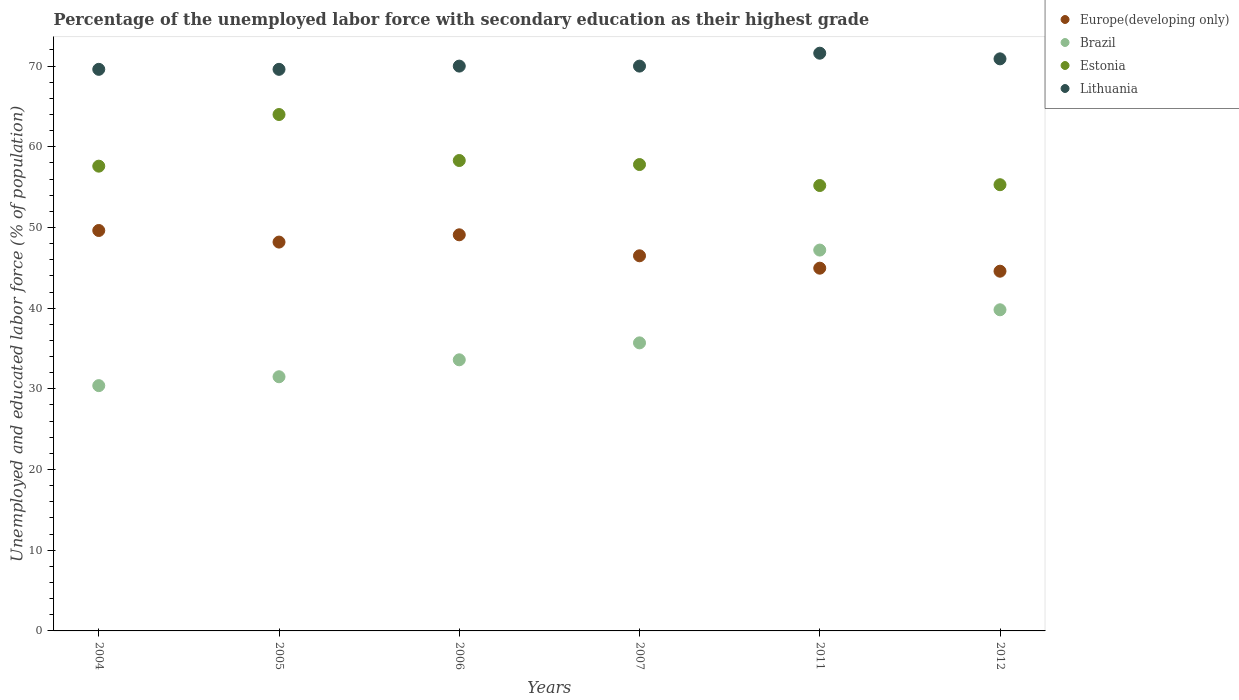Is the number of dotlines equal to the number of legend labels?
Give a very brief answer. Yes. What is the percentage of the unemployed labor force with secondary education in Lithuania in 2011?
Your answer should be compact. 71.6. Across all years, what is the maximum percentage of the unemployed labor force with secondary education in Lithuania?
Your answer should be very brief. 71.6. Across all years, what is the minimum percentage of the unemployed labor force with secondary education in Brazil?
Offer a very short reply. 30.4. In which year was the percentage of the unemployed labor force with secondary education in Europe(developing only) maximum?
Give a very brief answer. 2004. In which year was the percentage of the unemployed labor force with secondary education in Europe(developing only) minimum?
Your answer should be compact. 2012. What is the total percentage of the unemployed labor force with secondary education in Brazil in the graph?
Your response must be concise. 218.2. What is the difference between the percentage of the unemployed labor force with secondary education in Lithuania in 2004 and the percentage of the unemployed labor force with secondary education in Europe(developing only) in 2012?
Provide a short and direct response. 25.02. What is the average percentage of the unemployed labor force with secondary education in Estonia per year?
Keep it short and to the point. 58.03. In the year 2012, what is the difference between the percentage of the unemployed labor force with secondary education in Estonia and percentage of the unemployed labor force with secondary education in Brazil?
Your answer should be compact. 15.5. In how many years, is the percentage of the unemployed labor force with secondary education in Estonia greater than 38 %?
Provide a short and direct response. 6. What is the ratio of the percentage of the unemployed labor force with secondary education in Brazil in 2005 to that in 2011?
Your response must be concise. 0.67. Is the percentage of the unemployed labor force with secondary education in Lithuania in 2007 less than that in 2011?
Provide a short and direct response. Yes. Is the difference between the percentage of the unemployed labor force with secondary education in Estonia in 2005 and 2012 greater than the difference between the percentage of the unemployed labor force with secondary education in Brazil in 2005 and 2012?
Offer a terse response. Yes. What is the difference between the highest and the second highest percentage of the unemployed labor force with secondary education in Estonia?
Give a very brief answer. 5.7. What is the difference between the highest and the lowest percentage of the unemployed labor force with secondary education in Europe(developing only)?
Ensure brevity in your answer.  5.04. In how many years, is the percentage of the unemployed labor force with secondary education in Lithuania greater than the average percentage of the unemployed labor force with secondary education in Lithuania taken over all years?
Provide a short and direct response. 2. Is the sum of the percentage of the unemployed labor force with secondary education in Europe(developing only) in 2005 and 2006 greater than the maximum percentage of the unemployed labor force with secondary education in Estonia across all years?
Keep it short and to the point. Yes. Is the percentage of the unemployed labor force with secondary education in Brazil strictly greater than the percentage of the unemployed labor force with secondary education in Lithuania over the years?
Keep it short and to the point. No. Is the percentage of the unemployed labor force with secondary education in Estonia strictly less than the percentage of the unemployed labor force with secondary education in Lithuania over the years?
Your response must be concise. Yes. How many dotlines are there?
Your answer should be very brief. 4. How many years are there in the graph?
Your answer should be compact. 6. What is the difference between two consecutive major ticks on the Y-axis?
Give a very brief answer. 10. Does the graph contain grids?
Your response must be concise. No. Where does the legend appear in the graph?
Offer a very short reply. Top right. How many legend labels are there?
Offer a very short reply. 4. What is the title of the graph?
Your answer should be compact. Percentage of the unemployed labor force with secondary education as their highest grade. Does "European Union" appear as one of the legend labels in the graph?
Make the answer very short. No. What is the label or title of the X-axis?
Your response must be concise. Years. What is the label or title of the Y-axis?
Your answer should be compact. Unemployed and educated labor force (% of population). What is the Unemployed and educated labor force (% of population) in Europe(developing only) in 2004?
Provide a succinct answer. 49.63. What is the Unemployed and educated labor force (% of population) of Brazil in 2004?
Provide a short and direct response. 30.4. What is the Unemployed and educated labor force (% of population) of Estonia in 2004?
Your answer should be very brief. 57.6. What is the Unemployed and educated labor force (% of population) of Lithuania in 2004?
Your answer should be compact. 69.6. What is the Unemployed and educated labor force (% of population) of Europe(developing only) in 2005?
Your response must be concise. 48.19. What is the Unemployed and educated labor force (% of population) in Brazil in 2005?
Make the answer very short. 31.5. What is the Unemployed and educated labor force (% of population) of Estonia in 2005?
Offer a terse response. 64. What is the Unemployed and educated labor force (% of population) of Lithuania in 2005?
Make the answer very short. 69.6. What is the Unemployed and educated labor force (% of population) of Europe(developing only) in 2006?
Offer a terse response. 49.09. What is the Unemployed and educated labor force (% of population) of Brazil in 2006?
Make the answer very short. 33.6. What is the Unemployed and educated labor force (% of population) of Estonia in 2006?
Your answer should be very brief. 58.3. What is the Unemployed and educated labor force (% of population) of Lithuania in 2006?
Offer a terse response. 70. What is the Unemployed and educated labor force (% of population) of Europe(developing only) in 2007?
Give a very brief answer. 46.49. What is the Unemployed and educated labor force (% of population) of Brazil in 2007?
Your answer should be compact. 35.7. What is the Unemployed and educated labor force (% of population) of Estonia in 2007?
Make the answer very short. 57.8. What is the Unemployed and educated labor force (% of population) in Europe(developing only) in 2011?
Keep it short and to the point. 44.96. What is the Unemployed and educated labor force (% of population) of Brazil in 2011?
Offer a terse response. 47.2. What is the Unemployed and educated labor force (% of population) in Estonia in 2011?
Make the answer very short. 55.2. What is the Unemployed and educated labor force (% of population) in Lithuania in 2011?
Give a very brief answer. 71.6. What is the Unemployed and educated labor force (% of population) of Europe(developing only) in 2012?
Offer a very short reply. 44.58. What is the Unemployed and educated labor force (% of population) of Brazil in 2012?
Provide a short and direct response. 39.8. What is the Unemployed and educated labor force (% of population) of Estonia in 2012?
Keep it short and to the point. 55.3. What is the Unemployed and educated labor force (% of population) of Lithuania in 2012?
Provide a short and direct response. 70.9. Across all years, what is the maximum Unemployed and educated labor force (% of population) of Europe(developing only)?
Your answer should be very brief. 49.63. Across all years, what is the maximum Unemployed and educated labor force (% of population) in Brazil?
Make the answer very short. 47.2. Across all years, what is the maximum Unemployed and educated labor force (% of population) of Lithuania?
Your response must be concise. 71.6. Across all years, what is the minimum Unemployed and educated labor force (% of population) in Europe(developing only)?
Offer a very short reply. 44.58. Across all years, what is the minimum Unemployed and educated labor force (% of population) in Brazil?
Provide a succinct answer. 30.4. Across all years, what is the minimum Unemployed and educated labor force (% of population) of Estonia?
Keep it short and to the point. 55.2. Across all years, what is the minimum Unemployed and educated labor force (% of population) in Lithuania?
Your answer should be very brief. 69.6. What is the total Unemployed and educated labor force (% of population) of Europe(developing only) in the graph?
Your answer should be very brief. 282.94. What is the total Unemployed and educated labor force (% of population) of Brazil in the graph?
Offer a very short reply. 218.2. What is the total Unemployed and educated labor force (% of population) in Estonia in the graph?
Provide a short and direct response. 348.2. What is the total Unemployed and educated labor force (% of population) of Lithuania in the graph?
Provide a succinct answer. 421.7. What is the difference between the Unemployed and educated labor force (% of population) of Europe(developing only) in 2004 and that in 2005?
Give a very brief answer. 1.44. What is the difference between the Unemployed and educated labor force (% of population) of Lithuania in 2004 and that in 2005?
Give a very brief answer. 0. What is the difference between the Unemployed and educated labor force (% of population) in Europe(developing only) in 2004 and that in 2006?
Your response must be concise. 0.53. What is the difference between the Unemployed and educated labor force (% of population) of Brazil in 2004 and that in 2006?
Your response must be concise. -3.2. What is the difference between the Unemployed and educated labor force (% of population) of Estonia in 2004 and that in 2006?
Your response must be concise. -0.7. What is the difference between the Unemployed and educated labor force (% of population) in Europe(developing only) in 2004 and that in 2007?
Keep it short and to the point. 3.14. What is the difference between the Unemployed and educated labor force (% of population) in Brazil in 2004 and that in 2007?
Provide a succinct answer. -5.3. What is the difference between the Unemployed and educated labor force (% of population) of Estonia in 2004 and that in 2007?
Your response must be concise. -0.2. What is the difference between the Unemployed and educated labor force (% of population) in Europe(developing only) in 2004 and that in 2011?
Offer a very short reply. 4.67. What is the difference between the Unemployed and educated labor force (% of population) in Brazil in 2004 and that in 2011?
Make the answer very short. -16.8. What is the difference between the Unemployed and educated labor force (% of population) of Estonia in 2004 and that in 2011?
Your response must be concise. 2.4. What is the difference between the Unemployed and educated labor force (% of population) of Lithuania in 2004 and that in 2011?
Ensure brevity in your answer.  -2. What is the difference between the Unemployed and educated labor force (% of population) of Europe(developing only) in 2004 and that in 2012?
Your response must be concise. 5.04. What is the difference between the Unemployed and educated labor force (% of population) in Brazil in 2004 and that in 2012?
Your answer should be compact. -9.4. What is the difference between the Unemployed and educated labor force (% of population) in Lithuania in 2004 and that in 2012?
Offer a terse response. -1.3. What is the difference between the Unemployed and educated labor force (% of population) in Europe(developing only) in 2005 and that in 2006?
Offer a terse response. -0.9. What is the difference between the Unemployed and educated labor force (% of population) in Estonia in 2005 and that in 2006?
Offer a very short reply. 5.7. What is the difference between the Unemployed and educated labor force (% of population) of Europe(developing only) in 2005 and that in 2007?
Offer a very short reply. 1.7. What is the difference between the Unemployed and educated labor force (% of population) in Brazil in 2005 and that in 2007?
Provide a succinct answer. -4.2. What is the difference between the Unemployed and educated labor force (% of population) of Estonia in 2005 and that in 2007?
Your answer should be very brief. 6.2. What is the difference between the Unemployed and educated labor force (% of population) of Lithuania in 2005 and that in 2007?
Make the answer very short. -0.4. What is the difference between the Unemployed and educated labor force (% of population) in Europe(developing only) in 2005 and that in 2011?
Provide a short and direct response. 3.23. What is the difference between the Unemployed and educated labor force (% of population) of Brazil in 2005 and that in 2011?
Give a very brief answer. -15.7. What is the difference between the Unemployed and educated labor force (% of population) in Estonia in 2005 and that in 2011?
Provide a short and direct response. 8.8. What is the difference between the Unemployed and educated labor force (% of population) in Europe(developing only) in 2005 and that in 2012?
Give a very brief answer. 3.61. What is the difference between the Unemployed and educated labor force (% of population) in Europe(developing only) in 2006 and that in 2007?
Provide a short and direct response. 2.6. What is the difference between the Unemployed and educated labor force (% of population) in Brazil in 2006 and that in 2007?
Make the answer very short. -2.1. What is the difference between the Unemployed and educated labor force (% of population) of Lithuania in 2006 and that in 2007?
Provide a short and direct response. 0. What is the difference between the Unemployed and educated labor force (% of population) in Europe(developing only) in 2006 and that in 2011?
Make the answer very short. 4.14. What is the difference between the Unemployed and educated labor force (% of population) in Brazil in 2006 and that in 2011?
Ensure brevity in your answer.  -13.6. What is the difference between the Unemployed and educated labor force (% of population) in Europe(developing only) in 2006 and that in 2012?
Give a very brief answer. 4.51. What is the difference between the Unemployed and educated labor force (% of population) in Brazil in 2006 and that in 2012?
Provide a succinct answer. -6.2. What is the difference between the Unemployed and educated labor force (% of population) in Europe(developing only) in 2007 and that in 2011?
Offer a terse response. 1.53. What is the difference between the Unemployed and educated labor force (% of population) in Brazil in 2007 and that in 2011?
Your answer should be very brief. -11.5. What is the difference between the Unemployed and educated labor force (% of population) in Lithuania in 2007 and that in 2011?
Ensure brevity in your answer.  -1.6. What is the difference between the Unemployed and educated labor force (% of population) in Europe(developing only) in 2007 and that in 2012?
Provide a short and direct response. 1.91. What is the difference between the Unemployed and educated labor force (% of population) in Lithuania in 2007 and that in 2012?
Your answer should be very brief. -0.9. What is the difference between the Unemployed and educated labor force (% of population) of Europe(developing only) in 2011 and that in 2012?
Provide a succinct answer. 0.37. What is the difference between the Unemployed and educated labor force (% of population) in Brazil in 2011 and that in 2012?
Ensure brevity in your answer.  7.4. What is the difference between the Unemployed and educated labor force (% of population) of Europe(developing only) in 2004 and the Unemployed and educated labor force (% of population) of Brazil in 2005?
Provide a short and direct response. 18.13. What is the difference between the Unemployed and educated labor force (% of population) in Europe(developing only) in 2004 and the Unemployed and educated labor force (% of population) in Estonia in 2005?
Ensure brevity in your answer.  -14.37. What is the difference between the Unemployed and educated labor force (% of population) in Europe(developing only) in 2004 and the Unemployed and educated labor force (% of population) in Lithuania in 2005?
Provide a short and direct response. -19.97. What is the difference between the Unemployed and educated labor force (% of population) of Brazil in 2004 and the Unemployed and educated labor force (% of population) of Estonia in 2005?
Keep it short and to the point. -33.6. What is the difference between the Unemployed and educated labor force (% of population) in Brazil in 2004 and the Unemployed and educated labor force (% of population) in Lithuania in 2005?
Offer a terse response. -39.2. What is the difference between the Unemployed and educated labor force (% of population) of Estonia in 2004 and the Unemployed and educated labor force (% of population) of Lithuania in 2005?
Provide a short and direct response. -12. What is the difference between the Unemployed and educated labor force (% of population) in Europe(developing only) in 2004 and the Unemployed and educated labor force (% of population) in Brazil in 2006?
Make the answer very short. 16.03. What is the difference between the Unemployed and educated labor force (% of population) of Europe(developing only) in 2004 and the Unemployed and educated labor force (% of population) of Estonia in 2006?
Your response must be concise. -8.67. What is the difference between the Unemployed and educated labor force (% of population) in Europe(developing only) in 2004 and the Unemployed and educated labor force (% of population) in Lithuania in 2006?
Make the answer very short. -20.37. What is the difference between the Unemployed and educated labor force (% of population) in Brazil in 2004 and the Unemployed and educated labor force (% of population) in Estonia in 2006?
Offer a very short reply. -27.9. What is the difference between the Unemployed and educated labor force (% of population) of Brazil in 2004 and the Unemployed and educated labor force (% of population) of Lithuania in 2006?
Provide a short and direct response. -39.6. What is the difference between the Unemployed and educated labor force (% of population) in Estonia in 2004 and the Unemployed and educated labor force (% of population) in Lithuania in 2006?
Give a very brief answer. -12.4. What is the difference between the Unemployed and educated labor force (% of population) in Europe(developing only) in 2004 and the Unemployed and educated labor force (% of population) in Brazil in 2007?
Keep it short and to the point. 13.93. What is the difference between the Unemployed and educated labor force (% of population) in Europe(developing only) in 2004 and the Unemployed and educated labor force (% of population) in Estonia in 2007?
Provide a succinct answer. -8.17. What is the difference between the Unemployed and educated labor force (% of population) of Europe(developing only) in 2004 and the Unemployed and educated labor force (% of population) of Lithuania in 2007?
Offer a very short reply. -20.37. What is the difference between the Unemployed and educated labor force (% of population) of Brazil in 2004 and the Unemployed and educated labor force (% of population) of Estonia in 2007?
Give a very brief answer. -27.4. What is the difference between the Unemployed and educated labor force (% of population) of Brazil in 2004 and the Unemployed and educated labor force (% of population) of Lithuania in 2007?
Your response must be concise. -39.6. What is the difference between the Unemployed and educated labor force (% of population) of Europe(developing only) in 2004 and the Unemployed and educated labor force (% of population) of Brazil in 2011?
Keep it short and to the point. 2.43. What is the difference between the Unemployed and educated labor force (% of population) in Europe(developing only) in 2004 and the Unemployed and educated labor force (% of population) in Estonia in 2011?
Ensure brevity in your answer.  -5.57. What is the difference between the Unemployed and educated labor force (% of population) of Europe(developing only) in 2004 and the Unemployed and educated labor force (% of population) of Lithuania in 2011?
Offer a terse response. -21.97. What is the difference between the Unemployed and educated labor force (% of population) of Brazil in 2004 and the Unemployed and educated labor force (% of population) of Estonia in 2011?
Offer a very short reply. -24.8. What is the difference between the Unemployed and educated labor force (% of population) in Brazil in 2004 and the Unemployed and educated labor force (% of population) in Lithuania in 2011?
Make the answer very short. -41.2. What is the difference between the Unemployed and educated labor force (% of population) of Estonia in 2004 and the Unemployed and educated labor force (% of population) of Lithuania in 2011?
Provide a succinct answer. -14. What is the difference between the Unemployed and educated labor force (% of population) in Europe(developing only) in 2004 and the Unemployed and educated labor force (% of population) in Brazil in 2012?
Offer a very short reply. 9.83. What is the difference between the Unemployed and educated labor force (% of population) of Europe(developing only) in 2004 and the Unemployed and educated labor force (% of population) of Estonia in 2012?
Offer a terse response. -5.67. What is the difference between the Unemployed and educated labor force (% of population) in Europe(developing only) in 2004 and the Unemployed and educated labor force (% of population) in Lithuania in 2012?
Keep it short and to the point. -21.27. What is the difference between the Unemployed and educated labor force (% of population) in Brazil in 2004 and the Unemployed and educated labor force (% of population) in Estonia in 2012?
Provide a succinct answer. -24.9. What is the difference between the Unemployed and educated labor force (% of population) of Brazil in 2004 and the Unemployed and educated labor force (% of population) of Lithuania in 2012?
Your answer should be compact. -40.5. What is the difference between the Unemployed and educated labor force (% of population) in Europe(developing only) in 2005 and the Unemployed and educated labor force (% of population) in Brazil in 2006?
Provide a succinct answer. 14.59. What is the difference between the Unemployed and educated labor force (% of population) in Europe(developing only) in 2005 and the Unemployed and educated labor force (% of population) in Estonia in 2006?
Provide a succinct answer. -10.11. What is the difference between the Unemployed and educated labor force (% of population) in Europe(developing only) in 2005 and the Unemployed and educated labor force (% of population) in Lithuania in 2006?
Ensure brevity in your answer.  -21.81. What is the difference between the Unemployed and educated labor force (% of population) of Brazil in 2005 and the Unemployed and educated labor force (% of population) of Estonia in 2006?
Make the answer very short. -26.8. What is the difference between the Unemployed and educated labor force (% of population) in Brazil in 2005 and the Unemployed and educated labor force (% of population) in Lithuania in 2006?
Your answer should be very brief. -38.5. What is the difference between the Unemployed and educated labor force (% of population) of Europe(developing only) in 2005 and the Unemployed and educated labor force (% of population) of Brazil in 2007?
Ensure brevity in your answer.  12.49. What is the difference between the Unemployed and educated labor force (% of population) of Europe(developing only) in 2005 and the Unemployed and educated labor force (% of population) of Estonia in 2007?
Your answer should be compact. -9.61. What is the difference between the Unemployed and educated labor force (% of population) in Europe(developing only) in 2005 and the Unemployed and educated labor force (% of population) in Lithuania in 2007?
Ensure brevity in your answer.  -21.81. What is the difference between the Unemployed and educated labor force (% of population) in Brazil in 2005 and the Unemployed and educated labor force (% of population) in Estonia in 2007?
Provide a succinct answer. -26.3. What is the difference between the Unemployed and educated labor force (% of population) of Brazil in 2005 and the Unemployed and educated labor force (% of population) of Lithuania in 2007?
Your response must be concise. -38.5. What is the difference between the Unemployed and educated labor force (% of population) of Europe(developing only) in 2005 and the Unemployed and educated labor force (% of population) of Brazil in 2011?
Make the answer very short. 0.99. What is the difference between the Unemployed and educated labor force (% of population) in Europe(developing only) in 2005 and the Unemployed and educated labor force (% of population) in Estonia in 2011?
Your response must be concise. -7.01. What is the difference between the Unemployed and educated labor force (% of population) in Europe(developing only) in 2005 and the Unemployed and educated labor force (% of population) in Lithuania in 2011?
Keep it short and to the point. -23.41. What is the difference between the Unemployed and educated labor force (% of population) of Brazil in 2005 and the Unemployed and educated labor force (% of population) of Estonia in 2011?
Keep it short and to the point. -23.7. What is the difference between the Unemployed and educated labor force (% of population) of Brazil in 2005 and the Unemployed and educated labor force (% of population) of Lithuania in 2011?
Provide a short and direct response. -40.1. What is the difference between the Unemployed and educated labor force (% of population) in Estonia in 2005 and the Unemployed and educated labor force (% of population) in Lithuania in 2011?
Your response must be concise. -7.6. What is the difference between the Unemployed and educated labor force (% of population) in Europe(developing only) in 2005 and the Unemployed and educated labor force (% of population) in Brazil in 2012?
Make the answer very short. 8.39. What is the difference between the Unemployed and educated labor force (% of population) in Europe(developing only) in 2005 and the Unemployed and educated labor force (% of population) in Estonia in 2012?
Ensure brevity in your answer.  -7.11. What is the difference between the Unemployed and educated labor force (% of population) in Europe(developing only) in 2005 and the Unemployed and educated labor force (% of population) in Lithuania in 2012?
Provide a short and direct response. -22.71. What is the difference between the Unemployed and educated labor force (% of population) in Brazil in 2005 and the Unemployed and educated labor force (% of population) in Estonia in 2012?
Your answer should be compact. -23.8. What is the difference between the Unemployed and educated labor force (% of population) in Brazil in 2005 and the Unemployed and educated labor force (% of population) in Lithuania in 2012?
Your response must be concise. -39.4. What is the difference between the Unemployed and educated labor force (% of population) in Europe(developing only) in 2006 and the Unemployed and educated labor force (% of population) in Brazil in 2007?
Your answer should be very brief. 13.39. What is the difference between the Unemployed and educated labor force (% of population) in Europe(developing only) in 2006 and the Unemployed and educated labor force (% of population) in Estonia in 2007?
Your answer should be very brief. -8.71. What is the difference between the Unemployed and educated labor force (% of population) of Europe(developing only) in 2006 and the Unemployed and educated labor force (% of population) of Lithuania in 2007?
Give a very brief answer. -20.91. What is the difference between the Unemployed and educated labor force (% of population) in Brazil in 2006 and the Unemployed and educated labor force (% of population) in Estonia in 2007?
Keep it short and to the point. -24.2. What is the difference between the Unemployed and educated labor force (% of population) in Brazil in 2006 and the Unemployed and educated labor force (% of population) in Lithuania in 2007?
Give a very brief answer. -36.4. What is the difference between the Unemployed and educated labor force (% of population) in Europe(developing only) in 2006 and the Unemployed and educated labor force (% of population) in Brazil in 2011?
Provide a short and direct response. 1.89. What is the difference between the Unemployed and educated labor force (% of population) of Europe(developing only) in 2006 and the Unemployed and educated labor force (% of population) of Estonia in 2011?
Your answer should be very brief. -6.11. What is the difference between the Unemployed and educated labor force (% of population) in Europe(developing only) in 2006 and the Unemployed and educated labor force (% of population) in Lithuania in 2011?
Keep it short and to the point. -22.51. What is the difference between the Unemployed and educated labor force (% of population) of Brazil in 2006 and the Unemployed and educated labor force (% of population) of Estonia in 2011?
Offer a terse response. -21.6. What is the difference between the Unemployed and educated labor force (% of population) of Brazil in 2006 and the Unemployed and educated labor force (% of population) of Lithuania in 2011?
Keep it short and to the point. -38. What is the difference between the Unemployed and educated labor force (% of population) of Estonia in 2006 and the Unemployed and educated labor force (% of population) of Lithuania in 2011?
Make the answer very short. -13.3. What is the difference between the Unemployed and educated labor force (% of population) of Europe(developing only) in 2006 and the Unemployed and educated labor force (% of population) of Brazil in 2012?
Give a very brief answer. 9.29. What is the difference between the Unemployed and educated labor force (% of population) in Europe(developing only) in 2006 and the Unemployed and educated labor force (% of population) in Estonia in 2012?
Your answer should be very brief. -6.21. What is the difference between the Unemployed and educated labor force (% of population) of Europe(developing only) in 2006 and the Unemployed and educated labor force (% of population) of Lithuania in 2012?
Provide a short and direct response. -21.81. What is the difference between the Unemployed and educated labor force (% of population) in Brazil in 2006 and the Unemployed and educated labor force (% of population) in Estonia in 2012?
Your response must be concise. -21.7. What is the difference between the Unemployed and educated labor force (% of population) in Brazil in 2006 and the Unemployed and educated labor force (% of population) in Lithuania in 2012?
Your answer should be compact. -37.3. What is the difference between the Unemployed and educated labor force (% of population) in Europe(developing only) in 2007 and the Unemployed and educated labor force (% of population) in Brazil in 2011?
Your answer should be compact. -0.71. What is the difference between the Unemployed and educated labor force (% of population) in Europe(developing only) in 2007 and the Unemployed and educated labor force (% of population) in Estonia in 2011?
Provide a short and direct response. -8.71. What is the difference between the Unemployed and educated labor force (% of population) of Europe(developing only) in 2007 and the Unemployed and educated labor force (% of population) of Lithuania in 2011?
Offer a terse response. -25.11. What is the difference between the Unemployed and educated labor force (% of population) of Brazil in 2007 and the Unemployed and educated labor force (% of population) of Estonia in 2011?
Ensure brevity in your answer.  -19.5. What is the difference between the Unemployed and educated labor force (% of population) in Brazil in 2007 and the Unemployed and educated labor force (% of population) in Lithuania in 2011?
Make the answer very short. -35.9. What is the difference between the Unemployed and educated labor force (% of population) in Europe(developing only) in 2007 and the Unemployed and educated labor force (% of population) in Brazil in 2012?
Offer a terse response. 6.69. What is the difference between the Unemployed and educated labor force (% of population) in Europe(developing only) in 2007 and the Unemployed and educated labor force (% of population) in Estonia in 2012?
Provide a short and direct response. -8.81. What is the difference between the Unemployed and educated labor force (% of population) in Europe(developing only) in 2007 and the Unemployed and educated labor force (% of population) in Lithuania in 2012?
Give a very brief answer. -24.41. What is the difference between the Unemployed and educated labor force (% of population) in Brazil in 2007 and the Unemployed and educated labor force (% of population) in Estonia in 2012?
Make the answer very short. -19.6. What is the difference between the Unemployed and educated labor force (% of population) of Brazil in 2007 and the Unemployed and educated labor force (% of population) of Lithuania in 2012?
Provide a short and direct response. -35.2. What is the difference between the Unemployed and educated labor force (% of population) in Estonia in 2007 and the Unemployed and educated labor force (% of population) in Lithuania in 2012?
Give a very brief answer. -13.1. What is the difference between the Unemployed and educated labor force (% of population) in Europe(developing only) in 2011 and the Unemployed and educated labor force (% of population) in Brazil in 2012?
Offer a terse response. 5.16. What is the difference between the Unemployed and educated labor force (% of population) in Europe(developing only) in 2011 and the Unemployed and educated labor force (% of population) in Estonia in 2012?
Keep it short and to the point. -10.34. What is the difference between the Unemployed and educated labor force (% of population) in Europe(developing only) in 2011 and the Unemployed and educated labor force (% of population) in Lithuania in 2012?
Your response must be concise. -25.94. What is the difference between the Unemployed and educated labor force (% of population) of Brazil in 2011 and the Unemployed and educated labor force (% of population) of Estonia in 2012?
Offer a very short reply. -8.1. What is the difference between the Unemployed and educated labor force (% of population) in Brazil in 2011 and the Unemployed and educated labor force (% of population) in Lithuania in 2012?
Offer a terse response. -23.7. What is the difference between the Unemployed and educated labor force (% of population) in Estonia in 2011 and the Unemployed and educated labor force (% of population) in Lithuania in 2012?
Your answer should be compact. -15.7. What is the average Unemployed and educated labor force (% of population) of Europe(developing only) per year?
Provide a short and direct response. 47.16. What is the average Unemployed and educated labor force (% of population) in Brazil per year?
Your response must be concise. 36.37. What is the average Unemployed and educated labor force (% of population) in Estonia per year?
Make the answer very short. 58.03. What is the average Unemployed and educated labor force (% of population) in Lithuania per year?
Your response must be concise. 70.28. In the year 2004, what is the difference between the Unemployed and educated labor force (% of population) in Europe(developing only) and Unemployed and educated labor force (% of population) in Brazil?
Ensure brevity in your answer.  19.23. In the year 2004, what is the difference between the Unemployed and educated labor force (% of population) in Europe(developing only) and Unemployed and educated labor force (% of population) in Estonia?
Give a very brief answer. -7.97. In the year 2004, what is the difference between the Unemployed and educated labor force (% of population) of Europe(developing only) and Unemployed and educated labor force (% of population) of Lithuania?
Keep it short and to the point. -19.97. In the year 2004, what is the difference between the Unemployed and educated labor force (% of population) in Brazil and Unemployed and educated labor force (% of population) in Estonia?
Give a very brief answer. -27.2. In the year 2004, what is the difference between the Unemployed and educated labor force (% of population) of Brazil and Unemployed and educated labor force (% of population) of Lithuania?
Make the answer very short. -39.2. In the year 2004, what is the difference between the Unemployed and educated labor force (% of population) of Estonia and Unemployed and educated labor force (% of population) of Lithuania?
Offer a terse response. -12. In the year 2005, what is the difference between the Unemployed and educated labor force (% of population) of Europe(developing only) and Unemployed and educated labor force (% of population) of Brazil?
Give a very brief answer. 16.69. In the year 2005, what is the difference between the Unemployed and educated labor force (% of population) of Europe(developing only) and Unemployed and educated labor force (% of population) of Estonia?
Your response must be concise. -15.81. In the year 2005, what is the difference between the Unemployed and educated labor force (% of population) in Europe(developing only) and Unemployed and educated labor force (% of population) in Lithuania?
Make the answer very short. -21.41. In the year 2005, what is the difference between the Unemployed and educated labor force (% of population) of Brazil and Unemployed and educated labor force (% of population) of Estonia?
Your answer should be very brief. -32.5. In the year 2005, what is the difference between the Unemployed and educated labor force (% of population) of Brazil and Unemployed and educated labor force (% of population) of Lithuania?
Keep it short and to the point. -38.1. In the year 2005, what is the difference between the Unemployed and educated labor force (% of population) in Estonia and Unemployed and educated labor force (% of population) in Lithuania?
Your answer should be very brief. -5.6. In the year 2006, what is the difference between the Unemployed and educated labor force (% of population) in Europe(developing only) and Unemployed and educated labor force (% of population) in Brazil?
Provide a succinct answer. 15.49. In the year 2006, what is the difference between the Unemployed and educated labor force (% of population) in Europe(developing only) and Unemployed and educated labor force (% of population) in Estonia?
Give a very brief answer. -9.21. In the year 2006, what is the difference between the Unemployed and educated labor force (% of population) of Europe(developing only) and Unemployed and educated labor force (% of population) of Lithuania?
Offer a very short reply. -20.91. In the year 2006, what is the difference between the Unemployed and educated labor force (% of population) of Brazil and Unemployed and educated labor force (% of population) of Estonia?
Offer a very short reply. -24.7. In the year 2006, what is the difference between the Unemployed and educated labor force (% of population) in Brazil and Unemployed and educated labor force (% of population) in Lithuania?
Provide a succinct answer. -36.4. In the year 2007, what is the difference between the Unemployed and educated labor force (% of population) of Europe(developing only) and Unemployed and educated labor force (% of population) of Brazil?
Your answer should be very brief. 10.79. In the year 2007, what is the difference between the Unemployed and educated labor force (% of population) of Europe(developing only) and Unemployed and educated labor force (% of population) of Estonia?
Make the answer very short. -11.31. In the year 2007, what is the difference between the Unemployed and educated labor force (% of population) of Europe(developing only) and Unemployed and educated labor force (% of population) of Lithuania?
Keep it short and to the point. -23.51. In the year 2007, what is the difference between the Unemployed and educated labor force (% of population) of Brazil and Unemployed and educated labor force (% of population) of Estonia?
Provide a short and direct response. -22.1. In the year 2007, what is the difference between the Unemployed and educated labor force (% of population) of Brazil and Unemployed and educated labor force (% of population) of Lithuania?
Ensure brevity in your answer.  -34.3. In the year 2011, what is the difference between the Unemployed and educated labor force (% of population) of Europe(developing only) and Unemployed and educated labor force (% of population) of Brazil?
Ensure brevity in your answer.  -2.24. In the year 2011, what is the difference between the Unemployed and educated labor force (% of population) of Europe(developing only) and Unemployed and educated labor force (% of population) of Estonia?
Provide a succinct answer. -10.24. In the year 2011, what is the difference between the Unemployed and educated labor force (% of population) in Europe(developing only) and Unemployed and educated labor force (% of population) in Lithuania?
Your answer should be compact. -26.64. In the year 2011, what is the difference between the Unemployed and educated labor force (% of population) of Brazil and Unemployed and educated labor force (% of population) of Estonia?
Keep it short and to the point. -8. In the year 2011, what is the difference between the Unemployed and educated labor force (% of population) of Brazil and Unemployed and educated labor force (% of population) of Lithuania?
Your answer should be compact. -24.4. In the year 2011, what is the difference between the Unemployed and educated labor force (% of population) in Estonia and Unemployed and educated labor force (% of population) in Lithuania?
Your answer should be very brief. -16.4. In the year 2012, what is the difference between the Unemployed and educated labor force (% of population) of Europe(developing only) and Unemployed and educated labor force (% of population) of Brazil?
Offer a terse response. 4.78. In the year 2012, what is the difference between the Unemployed and educated labor force (% of population) of Europe(developing only) and Unemployed and educated labor force (% of population) of Estonia?
Ensure brevity in your answer.  -10.72. In the year 2012, what is the difference between the Unemployed and educated labor force (% of population) of Europe(developing only) and Unemployed and educated labor force (% of population) of Lithuania?
Your answer should be compact. -26.32. In the year 2012, what is the difference between the Unemployed and educated labor force (% of population) in Brazil and Unemployed and educated labor force (% of population) in Estonia?
Ensure brevity in your answer.  -15.5. In the year 2012, what is the difference between the Unemployed and educated labor force (% of population) in Brazil and Unemployed and educated labor force (% of population) in Lithuania?
Keep it short and to the point. -31.1. In the year 2012, what is the difference between the Unemployed and educated labor force (% of population) of Estonia and Unemployed and educated labor force (% of population) of Lithuania?
Provide a short and direct response. -15.6. What is the ratio of the Unemployed and educated labor force (% of population) of Europe(developing only) in 2004 to that in 2005?
Give a very brief answer. 1.03. What is the ratio of the Unemployed and educated labor force (% of population) of Brazil in 2004 to that in 2005?
Your answer should be compact. 0.97. What is the ratio of the Unemployed and educated labor force (% of population) in Estonia in 2004 to that in 2005?
Offer a very short reply. 0.9. What is the ratio of the Unemployed and educated labor force (% of population) in Lithuania in 2004 to that in 2005?
Give a very brief answer. 1. What is the ratio of the Unemployed and educated labor force (% of population) in Europe(developing only) in 2004 to that in 2006?
Make the answer very short. 1.01. What is the ratio of the Unemployed and educated labor force (% of population) of Brazil in 2004 to that in 2006?
Offer a very short reply. 0.9. What is the ratio of the Unemployed and educated labor force (% of population) of Estonia in 2004 to that in 2006?
Offer a very short reply. 0.99. What is the ratio of the Unemployed and educated labor force (% of population) in Lithuania in 2004 to that in 2006?
Provide a succinct answer. 0.99. What is the ratio of the Unemployed and educated labor force (% of population) in Europe(developing only) in 2004 to that in 2007?
Provide a succinct answer. 1.07. What is the ratio of the Unemployed and educated labor force (% of population) of Brazil in 2004 to that in 2007?
Make the answer very short. 0.85. What is the ratio of the Unemployed and educated labor force (% of population) in Estonia in 2004 to that in 2007?
Ensure brevity in your answer.  1. What is the ratio of the Unemployed and educated labor force (% of population) of Europe(developing only) in 2004 to that in 2011?
Ensure brevity in your answer.  1.1. What is the ratio of the Unemployed and educated labor force (% of population) of Brazil in 2004 to that in 2011?
Provide a succinct answer. 0.64. What is the ratio of the Unemployed and educated labor force (% of population) in Estonia in 2004 to that in 2011?
Your answer should be very brief. 1.04. What is the ratio of the Unemployed and educated labor force (% of population) in Lithuania in 2004 to that in 2011?
Provide a succinct answer. 0.97. What is the ratio of the Unemployed and educated labor force (% of population) in Europe(developing only) in 2004 to that in 2012?
Make the answer very short. 1.11. What is the ratio of the Unemployed and educated labor force (% of population) of Brazil in 2004 to that in 2012?
Give a very brief answer. 0.76. What is the ratio of the Unemployed and educated labor force (% of population) in Estonia in 2004 to that in 2012?
Make the answer very short. 1.04. What is the ratio of the Unemployed and educated labor force (% of population) in Lithuania in 2004 to that in 2012?
Provide a succinct answer. 0.98. What is the ratio of the Unemployed and educated labor force (% of population) of Europe(developing only) in 2005 to that in 2006?
Provide a succinct answer. 0.98. What is the ratio of the Unemployed and educated labor force (% of population) in Brazil in 2005 to that in 2006?
Your answer should be compact. 0.94. What is the ratio of the Unemployed and educated labor force (% of population) in Estonia in 2005 to that in 2006?
Ensure brevity in your answer.  1.1. What is the ratio of the Unemployed and educated labor force (% of population) of Lithuania in 2005 to that in 2006?
Your answer should be very brief. 0.99. What is the ratio of the Unemployed and educated labor force (% of population) in Europe(developing only) in 2005 to that in 2007?
Give a very brief answer. 1.04. What is the ratio of the Unemployed and educated labor force (% of population) of Brazil in 2005 to that in 2007?
Keep it short and to the point. 0.88. What is the ratio of the Unemployed and educated labor force (% of population) of Estonia in 2005 to that in 2007?
Keep it short and to the point. 1.11. What is the ratio of the Unemployed and educated labor force (% of population) of Lithuania in 2005 to that in 2007?
Provide a short and direct response. 0.99. What is the ratio of the Unemployed and educated labor force (% of population) in Europe(developing only) in 2005 to that in 2011?
Your answer should be compact. 1.07. What is the ratio of the Unemployed and educated labor force (% of population) in Brazil in 2005 to that in 2011?
Provide a succinct answer. 0.67. What is the ratio of the Unemployed and educated labor force (% of population) in Estonia in 2005 to that in 2011?
Keep it short and to the point. 1.16. What is the ratio of the Unemployed and educated labor force (% of population) of Lithuania in 2005 to that in 2011?
Provide a succinct answer. 0.97. What is the ratio of the Unemployed and educated labor force (% of population) of Europe(developing only) in 2005 to that in 2012?
Offer a very short reply. 1.08. What is the ratio of the Unemployed and educated labor force (% of population) of Brazil in 2005 to that in 2012?
Provide a short and direct response. 0.79. What is the ratio of the Unemployed and educated labor force (% of population) in Estonia in 2005 to that in 2012?
Ensure brevity in your answer.  1.16. What is the ratio of the Unemployed and educated labor force (% of population) in Lithuania in 2005 to that in 2012?
Your answer should be very brief. 0.98. What is the ratio of the Unemployed and educated labor force (% of population) in Europe(developing only) in 2006 to that in 2007?
Your answer should be compact. 1.06. What is the ratio of the Unemployed and educated labor force (% of population) of Estonia in 2006 to that in 2007?
Provide a succinct answer. 1.01. What is the ratio of the Unemployed and educated labor force (% of population) of Lithuania in 2006 to that in 2007?
Make the answer very short. 1. What is the ratio of the Unemployed and educated labor force (% of population) in Europe(developing only) in 2006 to that in 2011?
Offer a very short reply. 1.09. What is the ratio of the Unemployed and educated labor force (% of population) in Brazil in 2006 to that in 2011?
Offer a terse response. 0.71. What is the ratio of the Unemployed and educated labor force (% of population) in Estonia in 2006 to that in 2011?
Provide a short and direct response. 1.06. What is the ratio of the Unemployed and educated labor force (% of population) of Lithuania in 2006 to that in 2011?
Keep it short and to the point. 0.98. What is the ratio of the Unemployed and educated labor force (% of population) of Europe(developing only) in 2006 to that in 2012?
Make the answer very short. 1.1. What is the ratio of the Unemployed and educated labor force (% of population) of Brazil in 2006 to that in 2012?
Give a very brief answer. 0.84. What is the ratio of the Unemployed and educated labor force (% of population) in Estonia in 2006 to that in 2012?
Provide a succinct answer. 1.05. What is the ratio of the Unemployed and educated labor force (% of population) in Lithuania in 2006 to that in 2012?
Your answer should be very brief. 0.99. What is the ratio of the Unemployed and educated labor force (% of population) in Europe(developing only) in 2007 to that in 2011?
Your answer should be very brief. 1.03. What is the ratio of the Unemployed and educated labor force (% of population) of Brazil in 2007 to that in 2011?
Your response must be concise. 0.76. What is the ratio of the Unemployed and educated labor force (% of population) in Estonia in 2007 to that in 2011?
Your response must be concise. 1.05. What is the ratio of the Unemployed and educated labor force (% of population) in Lithuania in 2007 to that in 2011?
Make the answer very short. 0.98. What is the ratio of the Unemployed and educated labor force (% of population) of Europe(developing only) in 2007 to that in 2012?
Provide a succinct answer. 1.04. What is the ratio of the Unemployed and educated labor force (% of population) in Brazil in 2007 to that in 2012?
Provide a succinct answer. 0.9. What is the ratio of the Unemployed and educated labor force (% of population) of Estonia in 2007 to that in 2012?
Provide a short and direct response. 1.05. What is the ratio of the Unemployed and educated labor force (% of population) of Lithuania in 2007 to that in 2012?
Provide a short and direct response. 0.99. What is the ratio of the Unemployed and educated labor force (% of population) in Europe(developing only) in 2011 to that in 2012?
Your response must be concise. 1.01. What is the ratio of the Unemployed and educated labor force (% of population) in Brazil in 2011 to that in 2012?
Your answer should be compact. 1.19. What is the ratio of the Unemployed and educated labor force (% of population) in Lithuania in 2011 to that in 2012?
Ensure brevity in your answer.  1.01. What is the difference between the highest and the second highest Unemployed and educated labor force (% of population) of Europe(developing only)?
Your answer should be very brief. 0.53. What is the difference between the highest and the second highest Unemployed and educated labor force (% of population) in Lithuania?
Keep it short and to the point. 0.7. What is the difference between the highest and the lowest Unemployed and educated labor force (% of population) in Europe(developing only)?
Your answer should be compact. 5.04. What is the difference between the highest and the lowest Unemployed and educated labor force (% of population) in Brazil?
Provide a short and direct response. 16.8. What is the difference between the highest and the lowest Unemployed and educated labor force (% of population) of Estonia?
Offer a very short reply. 8.8. What is the difference between the highest and the lowest Unemployed and educated labor force (% of population) in Lithuania?
Provide a short and direct response. 2. 